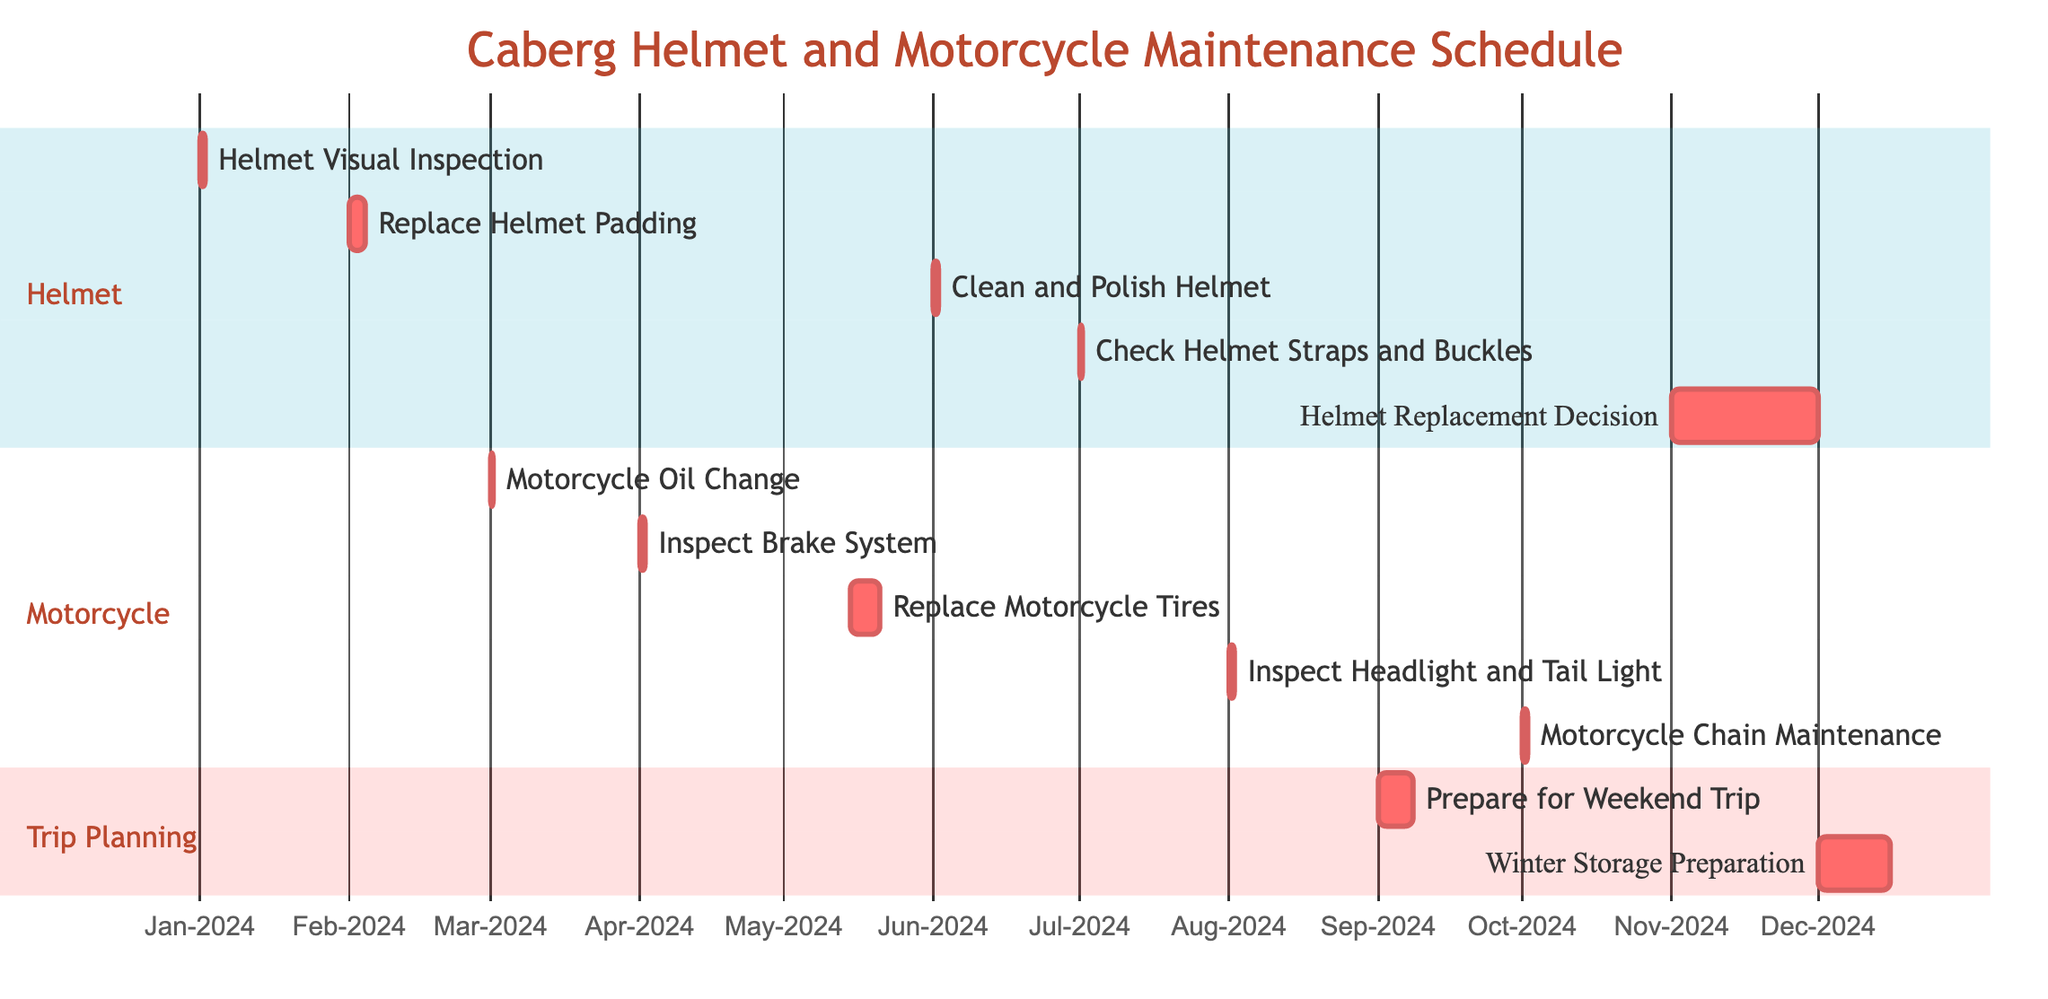what is the first maintenance task scheduled for the helmet? The first maintenance task listed in the diagram is "Helmet Visual Inspection." It appears at the top of the helmet section and is scheduled for January 1, 2024.
Answer: Helmet Visual Inspection how many days are allocated for replacing the helmet padding? The task "Replace Helmet Padding" has a duration of 3 days, as indicated in the diagram. It starts on February 1, 2024, and ends on February 3, 2024.
Answer: 3 days which task follows the "Inspect Brake System" for the motorcycle maintenance? The "Replace Motorcycle Tires" task follows the "Inspect Brake System" task on the timeline. The "Inspect Brake System" is scheduled for April 1, 2024, and "Replace Motorcycle Tires" starts on May 15, 2024.
Answer: Replace Motorcycle Tires what is the total duration of the tasks related to preparation for a weekend trip? The task "Prepare for Weekend Trip" spans 7 days from September 1, 2024, to September 7, 2024. The "Winter Storage Preparation" task spans 15 days from December 1, 2024, to December 15, 2024. Adding both durations together gives a total of 22 days.
Answer: 22 days how many maintenance tasks are scheduled for the helmet? There are a total of five maintenance tasks scheduled for the helmet throughout the year, as listed in the diagram.
Answer: 5 tasks which motorcycle maintenance task occurs last in the schedule? The last motorcycle maintenance task in the schedule is "Motorcycle Chain Maintenance," which occurs on October 1, 2024.
Answer: Motorcycle Chain Maintenance what is the date range for the helmet replacement decision task? The helmet replacement decision task runs from November 1, 2024, to November 30, 2024. This can be identified directly from the timeline of tasks in the helmet section of the diagram.
Answer: November 1 to November 30, 2024 which task is scheduled just before "Winter Storage Preparation"? The "Prepare for Weekend Trip" task is scheduled just before the "Winter Storage Preparation," beginning on September 1, 2024, and ending on September 7, 2024.
Answer: Prepare for Weekend Trip 